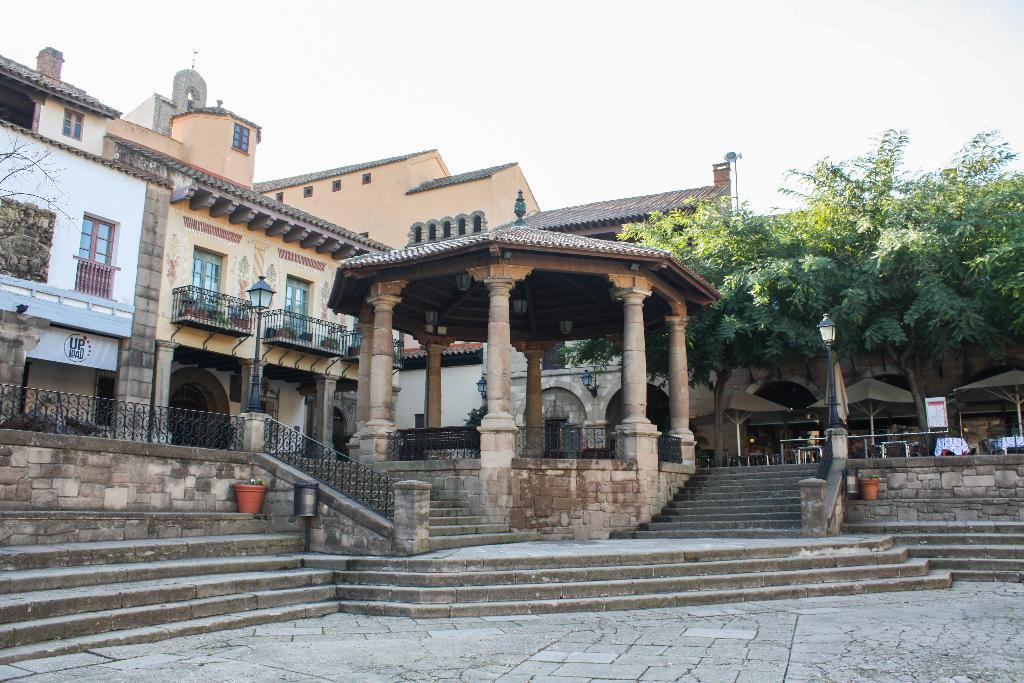What is the main structure in the middle of the image? There is a building in the middle of the image. What architectural feature can be seen in the image? There are staircases in the image. What type of vegetation is on the right side of the image? There are trees on the right side of the image. What is visible at the top of the image? The sky is visible at the top of the image. How would you describe the sky in the image? The sky appears to be cloudy. Where is the shop located in the image? There is no shop present in the image. Can you see any seeds in the image? There are no seeds visible in the image. 